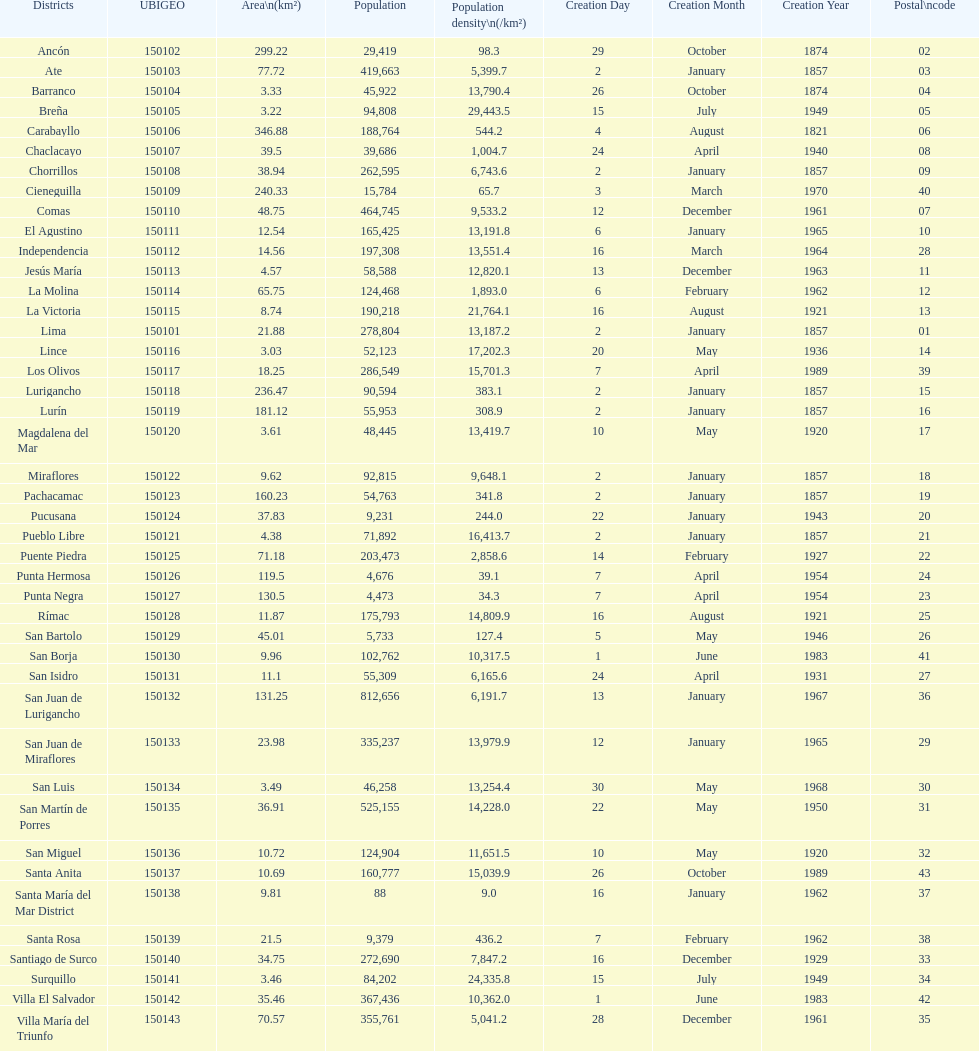Which is the largest district in terms of population? San Juan de Lurigancho. 